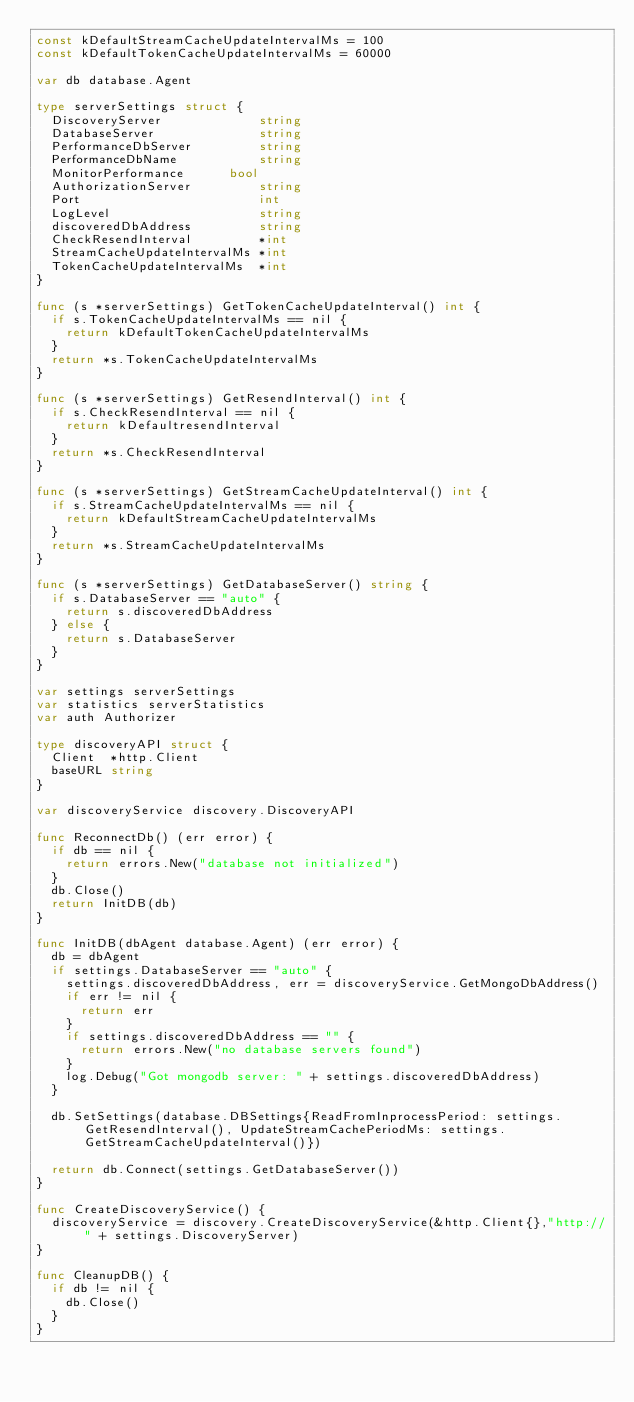Convert code to text. <code><loc_0><loc_0><loc_500><loc_500><_Go_>const kDefaultStreamCacheUpdateIntervalMs = 100
const kDefaultTokenCacheUpdateIntervalMs = 60000

var db database.Agent

type serverSettings struct {
	DiscoveryServer             string
	DatabaseServer              string
	PerformanceDbServer         string
	PerformanceDbName           string
	MonitorPerformance 			bool
	AuthorizationServer         string
	Port                        int
	LogLevel                    string
	discoveredDbAddress         string
	CheckResendInterval         *int
	StreamCacheUpdateIntervalMs *int
	TokenCacheUpdateIntervalMs  *int
}

func (s *serverSettings) GetTokenCacheUpdateInterval() int {
	if s.TokenCacheUpdateIntervalMs == nil {
		return kDefaultTokenCacheUpdateIntervalMs
	}
	return *s.TokenCacheUpdateIntervalMs
}

func (s *serverSettings) GetResendInterval() int {
	if s.CheckResendInterval == nil {
		return kDefaultresendInterval
	}
	return *s.CheckResendInterval
}

func (s *serverSettings) GetStreamCacheUpdateInterval() int {
	if s.StreamCacheUpdateIntervalMs == nil {
		return kDefaultStreamCacheUpdateIntervalMs
	}
	return *s.StreamCacheUpdateIntervalMs
}

func (s *serverSettings) GetDatabaseServer() string {
	if s.DatabaseServer == "auto" {
		return s.discoveredDbAddress
	} else {
		return s.DatabaseServer
	}
}

var settings serverSettings
var statistics serverStatistics
var auth Authorizer

type discoveryAPI struct {
	Client  *http.Client
	baseURL string
}

var discoveryService discovery.DiscoveryAPI

func ReconnectDb() (err error) {
	if db == nil {
		return errors.New("database not initialized")
	}
	db.Close()
	return InitDB(db)
}

func InitDB(dbAgent database.Agent) (err error) {
	db = dbAgent
	if settings.DatabaseServer == "auto" {
		settings.discoveredDbAddress, err = discoveryService.GetMongoDbAddress()
		if err != nil {
			return err
		}
		if settings.discoveredDbAddress == "" {
			return errors.New("no database servers found")
		}
		log.Debug("Got mongodb server: " + settings.discoveredDbAddress)
	}

	db.SetSettings(database.DBSettings{ReadFromInprocessPeriod: settings.GetResendInterval(), UpdateStreamCachePeriodMs: settings.GetStreamCacheUpdateInterval()})

	return db.Connect(settings.GetDatabaseServer())
}

func CreateDiscoveryService() {
	discoveryService = discovery.CreateDiscoveryService(&http.Client{},"http://" + settings.DiscoveryServer)
}

func CleanupDB() {
	if db != nil {
		db.Close()
	}
}
</code> 